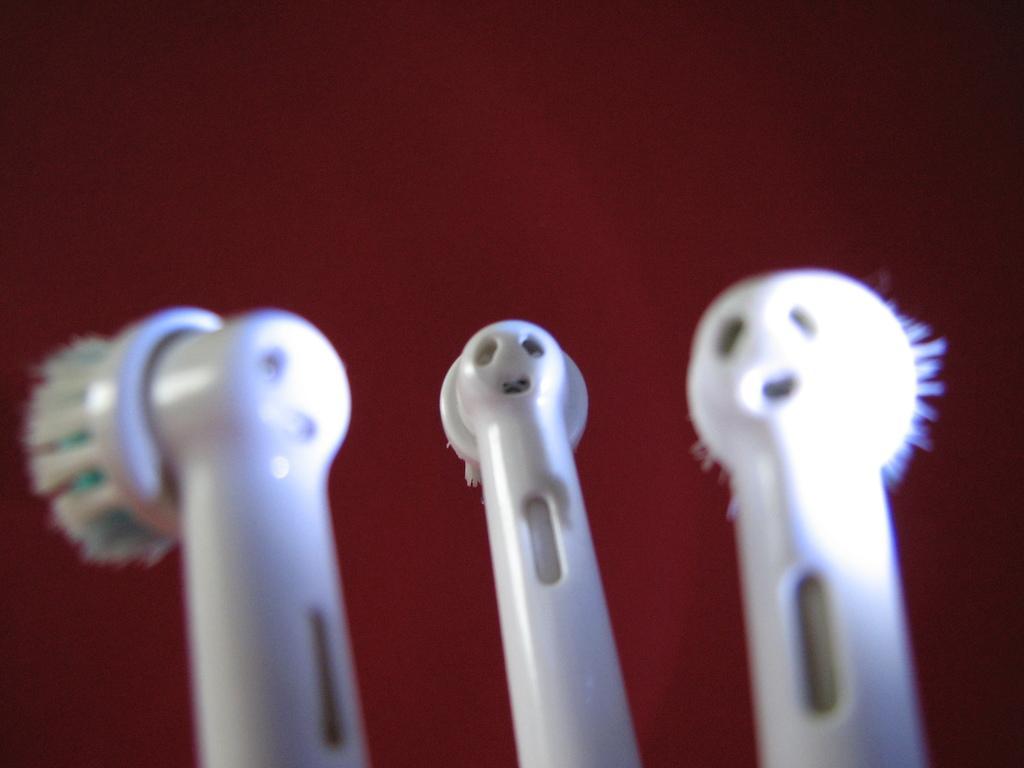Please provide a concise description of this image. This picture contains three electric toothbrushes. These brushes are in white color. In the background, it is in maroon color. 